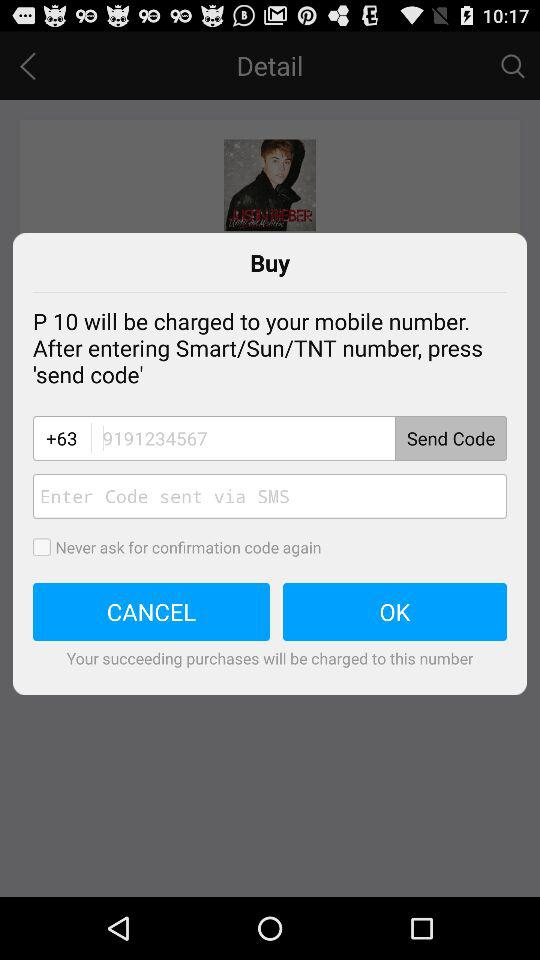What's the status of "Never ask for confirmation code again"? The status is "off". 